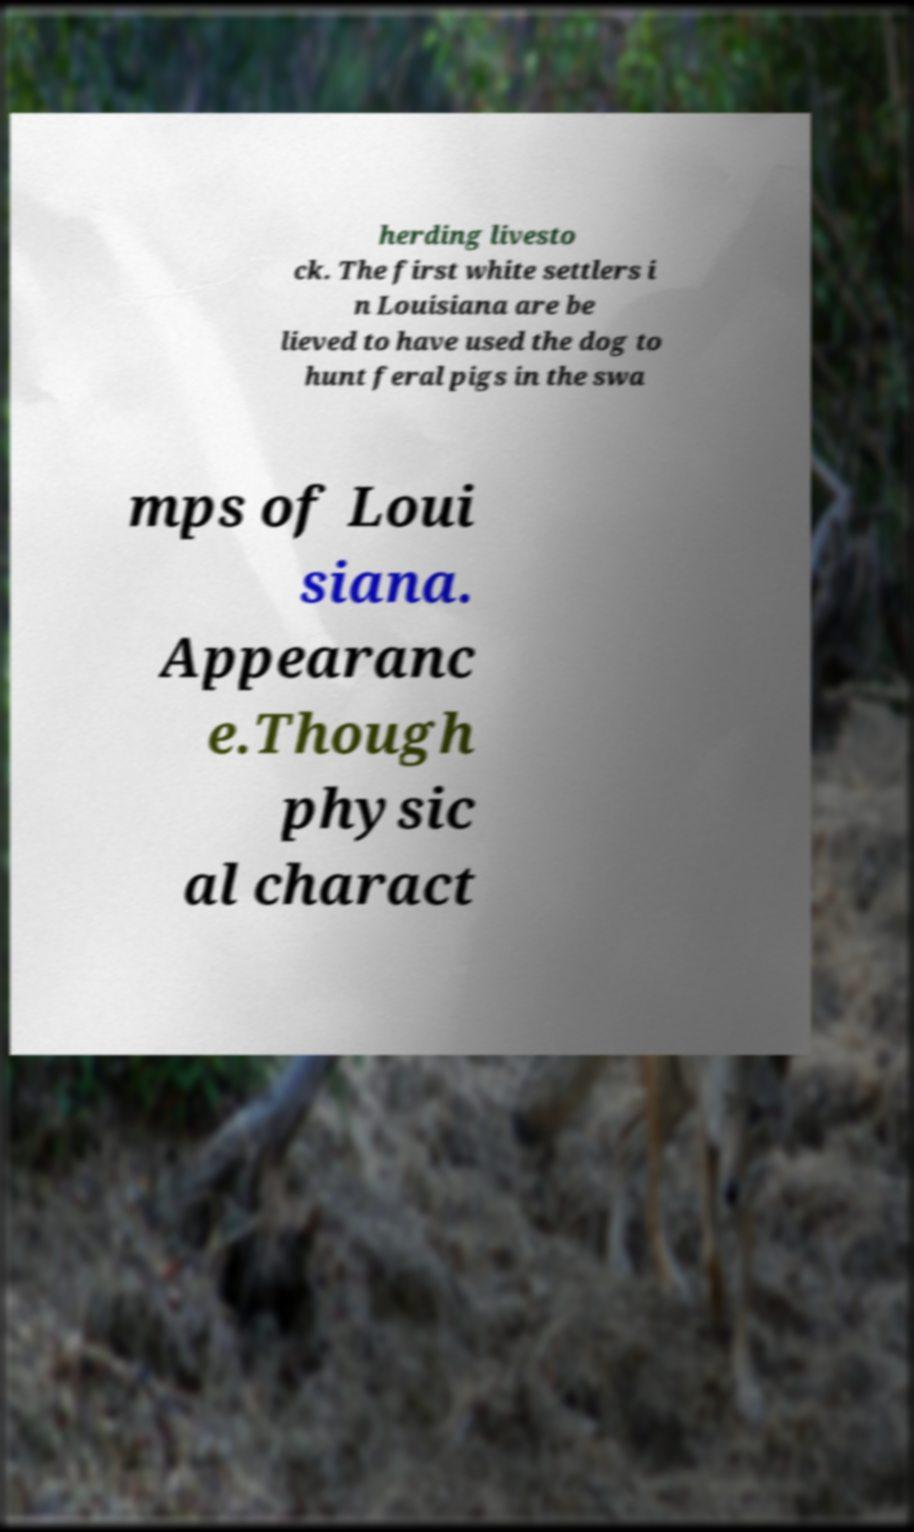Can you read and provide the text displayed in the image?This photo seems to have some interesting text. Can you extract and type it out for me? herding livesto ck. The first white settlers i n Louisiana are be lieved to have used the dog to hunt feral pigs in the swa mps of Loui siana. Appearanc e.Though physic al charact 